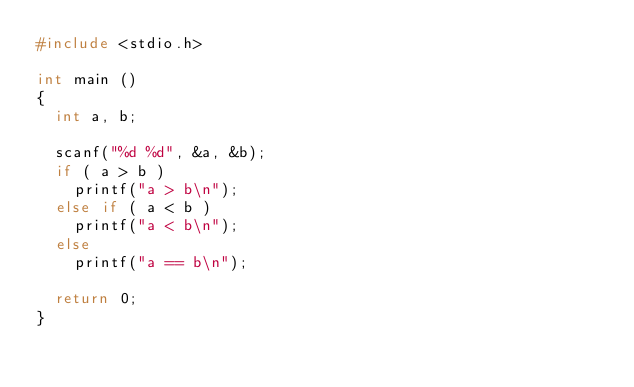Convert code to text. <code><loc_0><loc_0><loc_500><loc_500><_C_>#include <stdio.h>

int main ()
{
	int a, b;

	scanf("%d %d", &a, &b);
	if ( a > b )
		printf("a > b\n");
	else if ( a < b )
		printf("a < b\n");
	else
		printf("a == b\n");

	return 0;
}</code> 